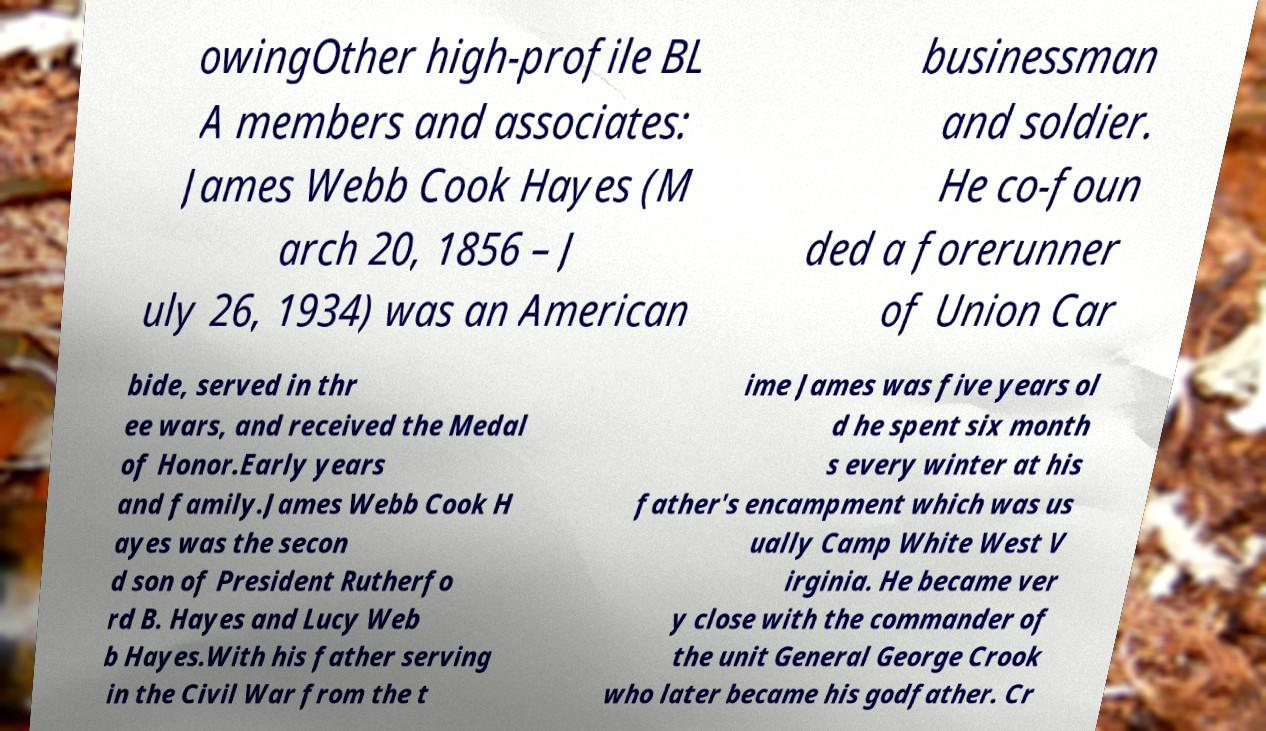Could you extract and type out the text from this image? owingOther high-profile BL A members and associates: James Webb Cook Hayes (M arch 20, 1856 – J uly 26, 1934) was an American businessman and soldier. He co-foun ded a forerunner of Union Car bide, served in thr ee wars, and received the Medal of Honor.Early years and family.James Webb Cook H ayes was the secon d son of President Rutherfo rd B. Hayes and Lucy Web b Hayes.With his father serving in the Civil War from the t ime James was five years ol d he spent six month s every winter at his father's encampment which was us ually Camp White West V irginia. He became ver y close with the commander of the unit General George Crook who later became his godfather. Cr 